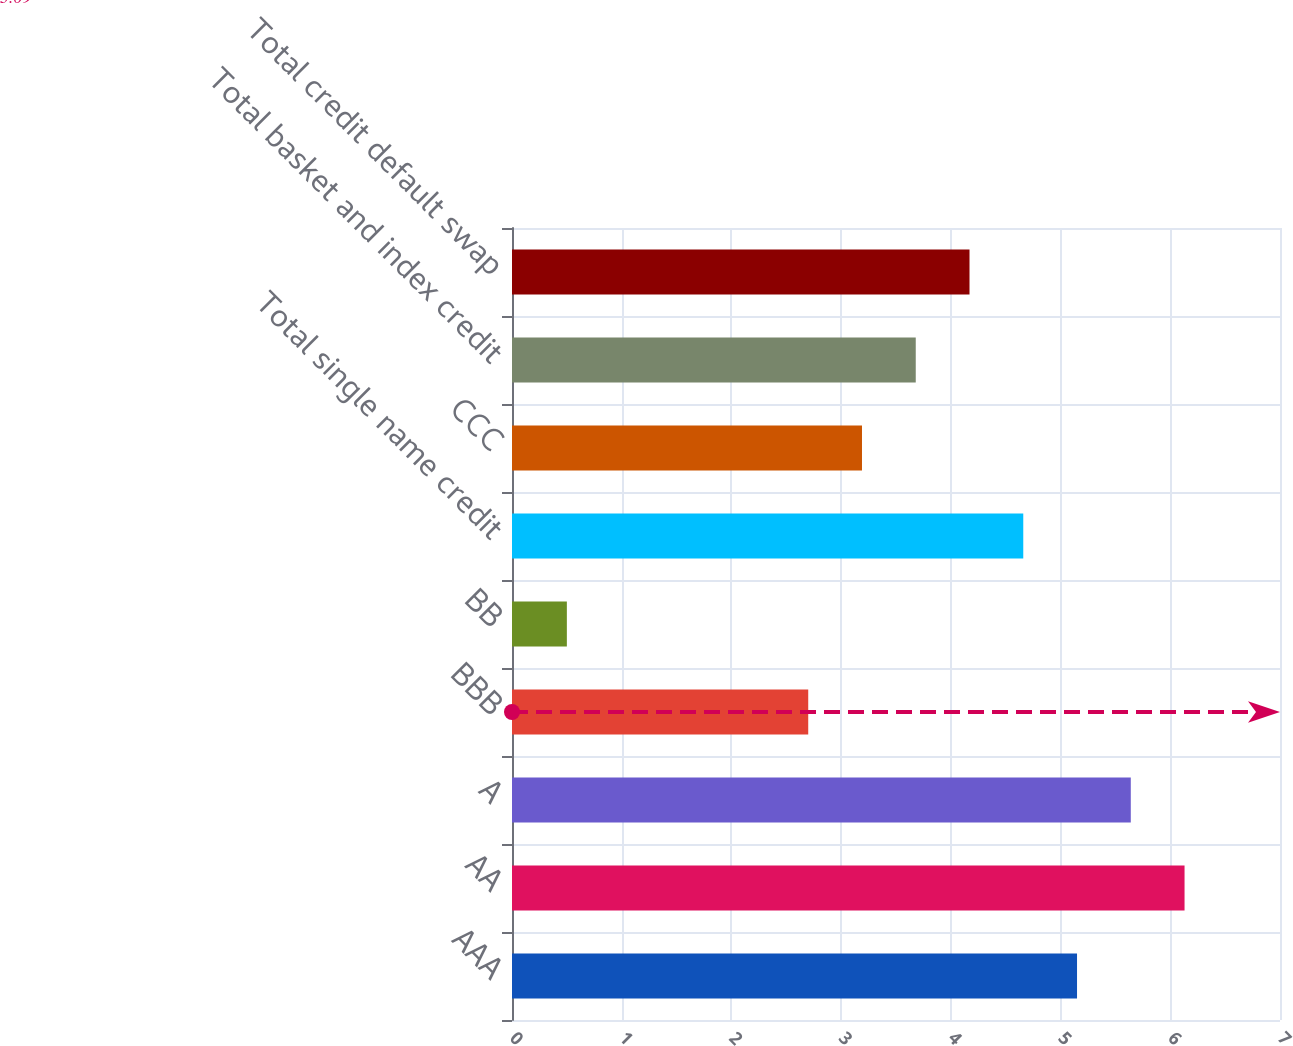Convert chart to OTSL. <chart><loc_0><loc_0><loc_500><loc_500><bar_chart><fcel>AAA<fcel>AA<fcel>A<fcel>BBB<fcel>BB<fcel>Total single name credit<fcel>CCC<fcel>Total basket and index credit<fcel>Total credit default swap<nl><fcel>5.15<fcel>6.13<fcel>5.64<fcel>2.7<fcel>0.5<fcel>4.66<fcel>3.19<fcel>3.68<fcel>4.17<nl></chart> 